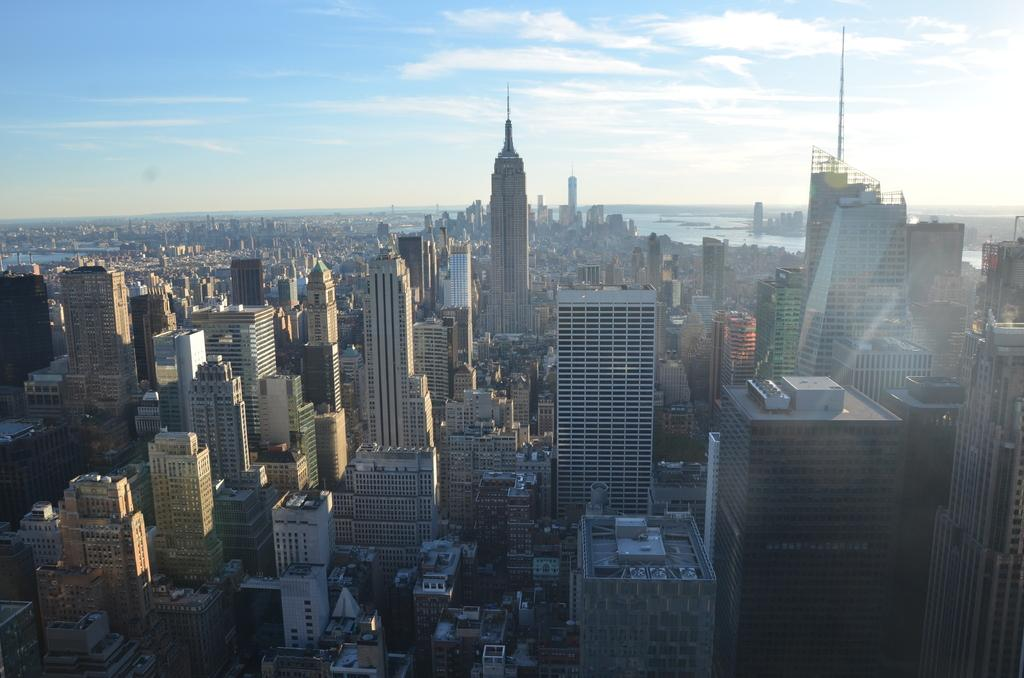What structures are located in the center of the image? There are buildings, houses, and skyscrapers in the center of the image. What type of natural feature can be seen in the background of the image? There is a sea in the background of the image. What is visible at the top of the image? The sky is visible at the top of the image. What type of low is present in the image? There is no reference to a "low" in the image, as it features buildings, houses, skyscrapers, a sea, and the sky. Can you tell me the name of the minister in the image? There is no minister present in the image. 